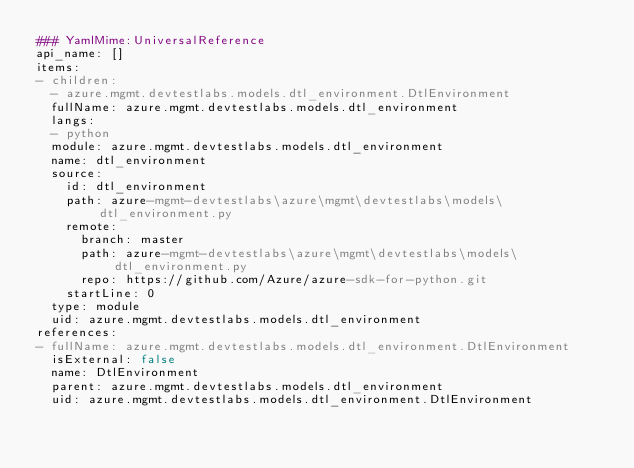Convert code to text. <code><loc_0><loc_0><loc_500><loc_500><_YAML_>### YamlMime:UniversalReference
api_name: []
items:
- children:
  - azure.mgmt.devtestlabs.models.dtl_environment.DtlEnvironment
  fullName: azure.mgmt.devtestlabs.models.dtl_environment
  langs:
  - python
  module: azure.mgmt.devtestlabs.models.dtl_environment
  name: dtl_environment
  source:
    id: dtl_environment
    path: azure-mgmt-devtestlabs\azure\mgmt\devtestlabs\models\dtl_environment.py
    remote:
      branch: master
      path: azure-mgmt-devtestlabs\azure\mgmt\devtestlabs\models\dtl_environment.py
      repo: https://github.com/Azure/azure-sdk-for-python.git
    startLine: 0
  type: module
  uid: azure.mgmt.devtestlabs.models.dtl_environment
references:
- fullName: azure.mgmt.devtestlabs.models.dtl_environment.DtlEnvironment
  isExternal: false
  name: DtlEnvironment
  parent: azure.mgmt.devtestlabs.models.dtl_environment
  uid: azure.mgmt.devtestlabs.models.dtl_environment.DtlEnvironment
</code> 